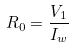Convert formula to latex. <formula><loc_0><loc_0><loc_500><loc_500>R _ { 0 } = \frac { V _ { 1 } } { I _ { w } }</formula> 